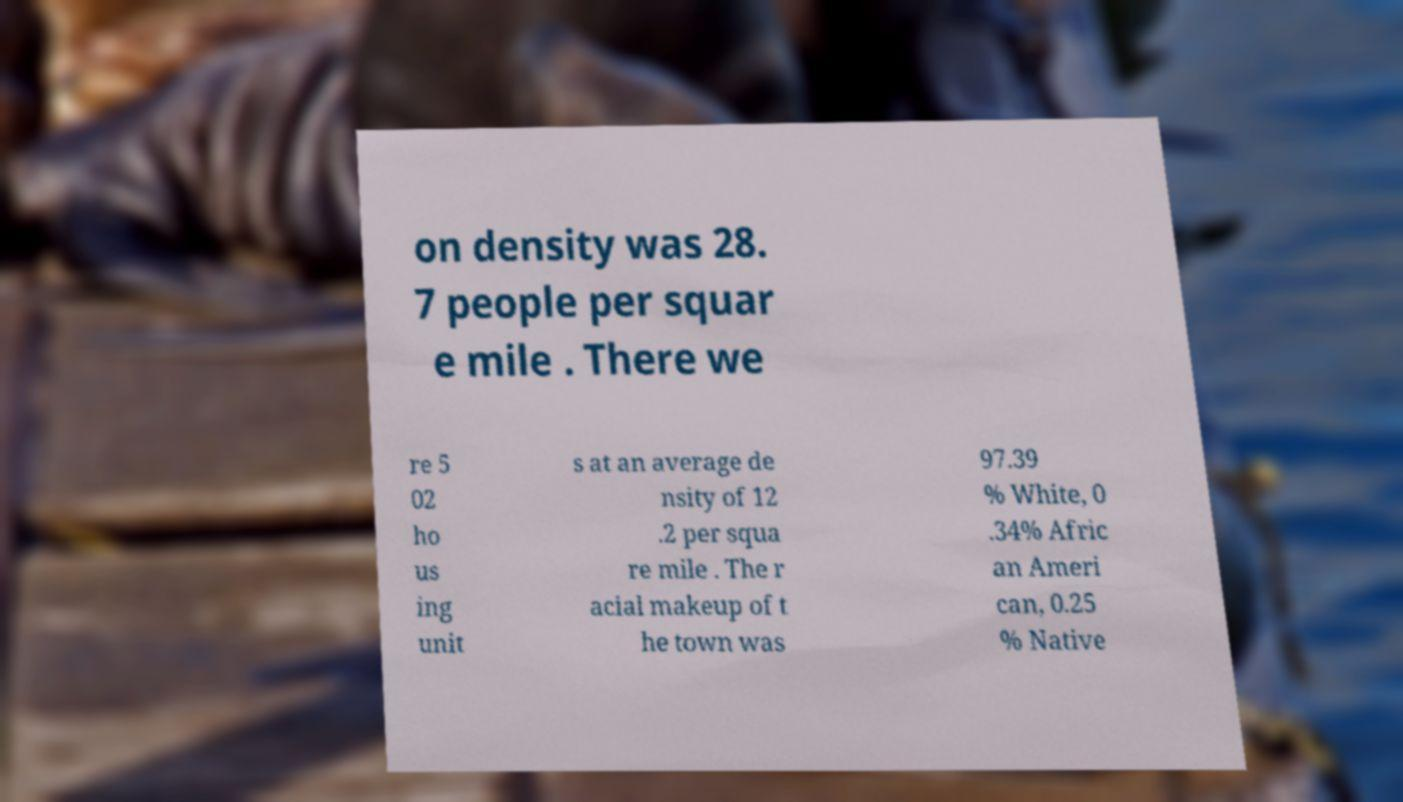For documentation purposes, I need the text within this image transcribed. Could you provide that? on density was 28. 7 people per squar e mile . There we re 5 02 ho us ing unit s at an average de nsity of 12 .2 per squa re mile . The r acial makeup of t he town was 97.39 % White, 0 .34% Afric an Ameri can, 0.25 % Native 